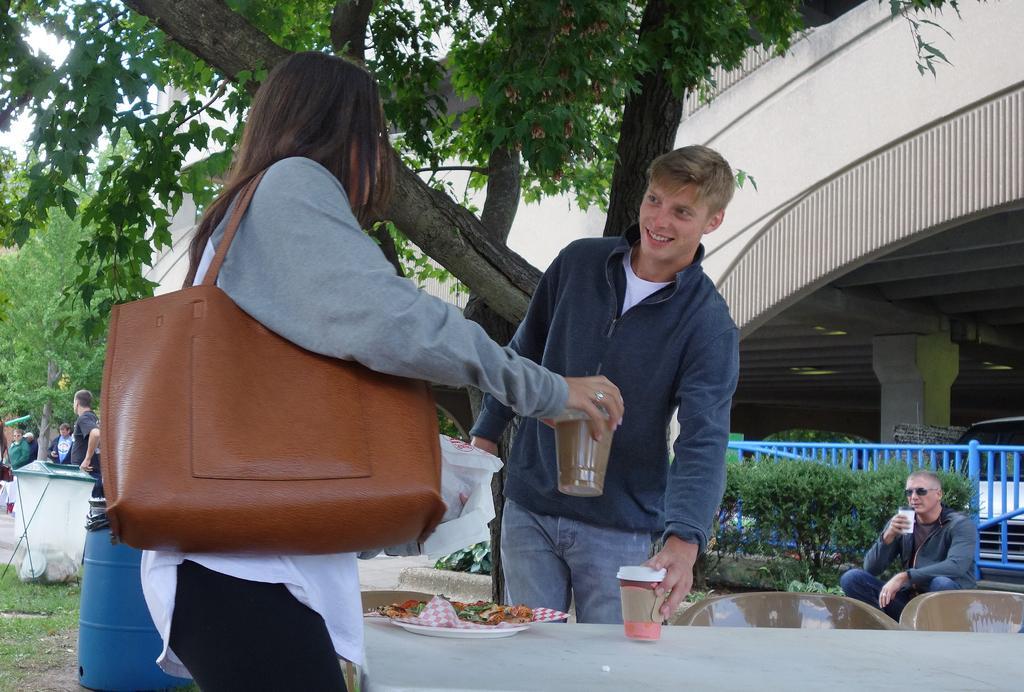In one or two sentences, can you explain what this image depicts? In the middle there is a man he wear jacket and trouser he is smiling. On the left there is a woman her hair is short she wear handbag. In the middle there is a table on that table there is a plate and cup. In the background there are some people ,trees ,plants and building. 